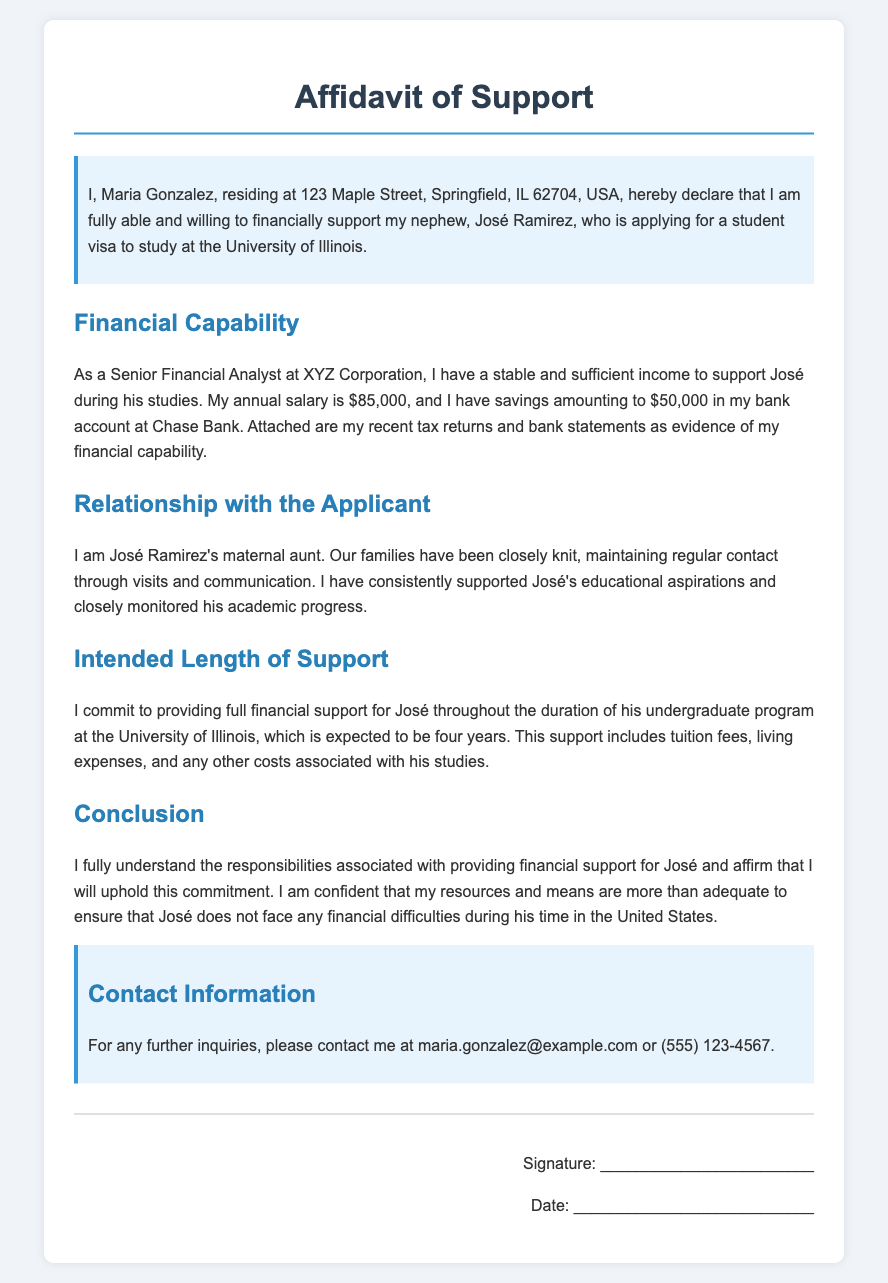What is the name of the person providing support? The document states that the person providing support is Maria Gonzalez.
Answer: Maria Gonzalez What is the applicant's name? The document mentions that the applicant is José Ramirez.
Answer: José Ramirez What is Maria Gonzalez's annual salary? According to the document, her annual salary is $85,000.
Answer: $85,000 How much savings does Maria have in her bank account? The document indicates that Maria has savings amounting to $50,000.
Answer: $50,000 What is the intended duration of support for José? The document specifies that the intended duration of support is four years.
Answer: four years What is the relationship between Maria and José? The affidavit states that Maria is José's maternal aunt.
Answer: maternal aunt What type of visa is José applying for? The document mentions that José is applying for a student visa.
Answer: student visa What university will José attend? The document indicates that José will attend the University of Illinois.
Answer: University of Illinois What form of evidence is attached to the affidavit? The document notes that recent tax returns and bank statements are attached as evidence.
Answer: tax returns and bank statements 